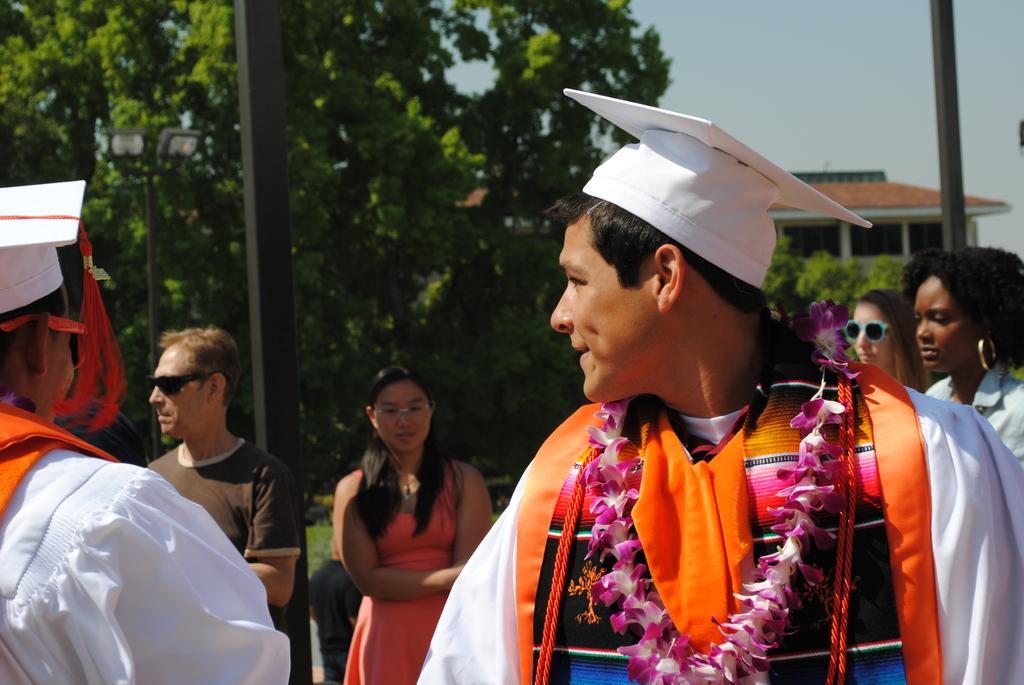Please provide a concise description of this image. In the middle a man is there, he wore white color cap and a garland. Here a beautiful woman is standing, she wore orange color dress beside him a man is there, he wore t-shirt, goggles. There are trees at the backside of an image. On the right side there is a house. 